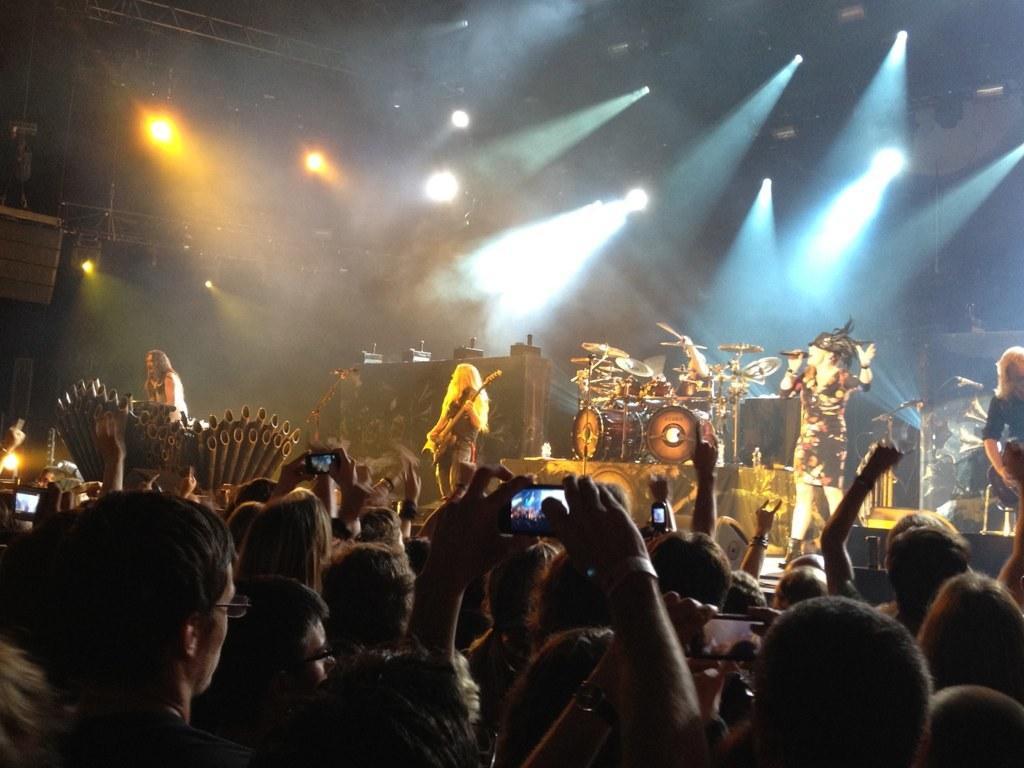Describe this image in one or two sentences. In the image there are people singing and playing music instruments on stage. on to ceiling there are many lights,in front many audience capturing on phones. 